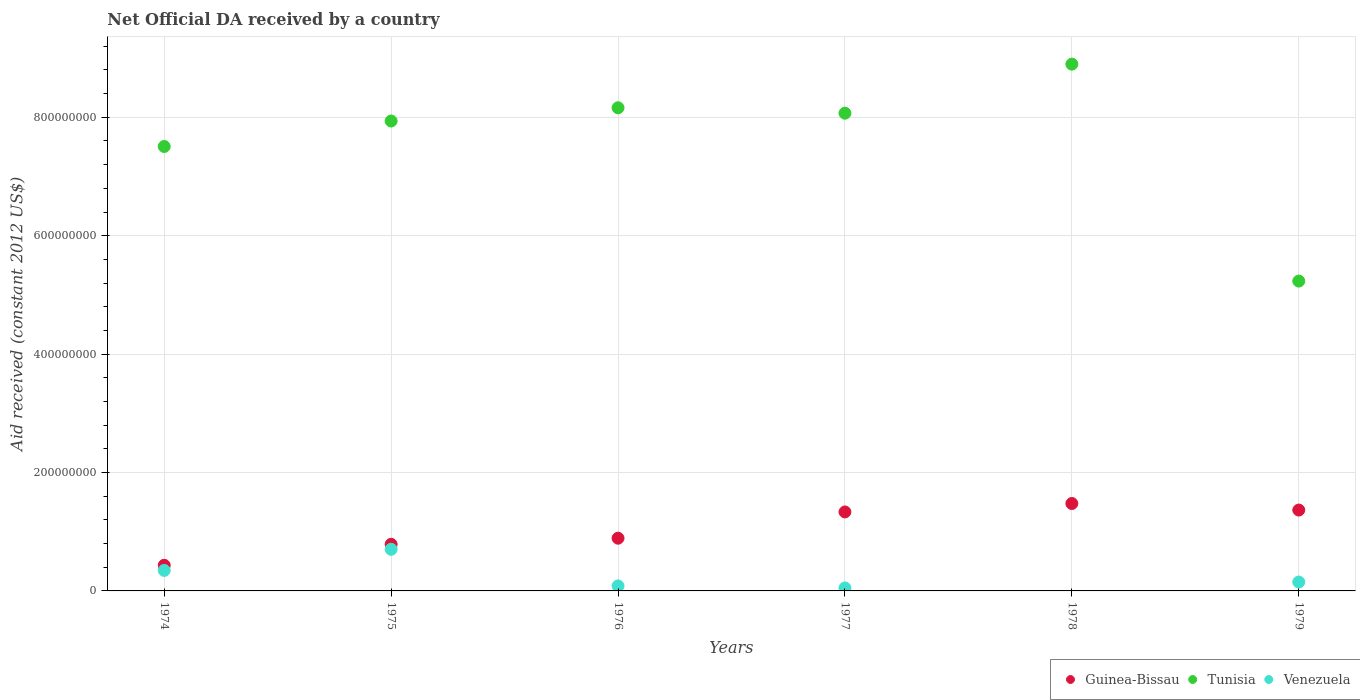How many different coloured dotlines are there?
Give a very brief answer. 3. Is the number of dotlines equal to the number of legend labels?
Provide a succinct answer. No. Across all years, what is the maximum net official development assistance aid received in Tunisia?
Your answer should be very brief. 8.90e+08. Across all years, what is the minimum net official development assistance aid received in Venezuela?
Ensure brevity in your answer.  0. In which year was the net official development assistance aid received in Guinea-Bissau maximum?
Ensure brevity in your answer.  1978. What is the total net official development assistance aid received in Venezuela in the graph?
Provide a short and direct response. 1.33e+08. What is the difference between the net official development assistance aid received in Guinea-Bissau in 1975 and that in 1976?
Offer a terse response. -1.03e+07. What is the difference between the net official development assistance aid received in Venezuela in 1979 and the net official development assistance aid received in Tunisia in 1978?
Keep it short and to the point. -8.75e+08. What is the average net official development assistance aid received in Guinea-Bissau per year?
Provide a succinct answer. 1.05e+08. In the year 1979, what is the difference between the net official development assistance aid received in Venezuela and net official development assistance aid received in Tunisia?
Provide a succinct answer. -5.08e+08. In how many years, is the net official development assistance aid received in Guinea-Bissau greater than 120000000 US$?
Give a very brief answer. 3. What is the ratio of the net official development assistance aid received in Guinea-Bissau in 1974 to that in 1976?
Ensure brevity in your answer.  0.49. Is the difference between the net official development assistance aid received in Venezuela in 1974 and 1979 greater than the difference between the net official development assistance aid received in Tunisia in 1974 and 1979?
Offer a very short reply. No. What is the difference between the highest and the second highest net official development assistance aid received in Guinea-Bissau?
Provide a short and direct response. 1.11e+07. What is the difference between the highest and the lowest net official development assistance aid received in Tunisia?
Provide a short and direct response. 3.66e+08. In how many years, is the net official development assistance aid received in Venezuela greater than the average net official development assistance aid received in Venezuela taken over all years?
Offer a very short reply. 2. Is it the case that in every year, the sum of the net official development assistance aid received in Tunisia and net official development assistance aid received in Venezuela  is greater than the net official development assistance aid received in Guinea-Bissau?
Ensure brevity in your answer.  Yes. Does the net official development assistance aid received in Venezuela monotonically increase over the years?
Your answer should be very brief. No. Is the net official development assistance aid received in Tunisia strictly greater than the net official development assistance aid received in Venezuela over the years?
Keep it short and to the point. Yes. Is the net official development assistance aid received in Tunisia strictly less than the net official development assistance aid received in Guinea-Bissau over the years?
Provide a short and direct response. No. How many years are there in the graph?
Provide a succinct answer. 6. What is the difference between two consecutive major ticks on the Y-axis?
Your answer should be very brief. 2.00e+08. Are the values on the major ticks of Y-axis written in scientific E-notation?
Your answer should be very brief. No. What is the title of the graph?
Make the answer very short. Net Official DA received by a country. Does "Central Europe" appear as one of the legend labels in the graph?
Provide a succinct answer. No. What is the label or title of the X-axis?
Keep it short and to the point. Years. What is the label or title of the Y-axis?
Keep it short and to the point. Aid received (constant 2012 US$). What is the Aid received (constant 2012 US$) in Guinea-Bissau in 1974?
Your answer should be compact. 4.33e+07. What is the Aid received (constant 2012 US$) in Tunisia in 1974?
Keep it short and to the point. 7.51e+08. What is the Aid received (constant 2012 US$) in Venezuela in 1974?
Your response must be concise. 3.46e+07. What is the Aid received (constant 2012 US$) of Guinea-Bissau in 1975?
Make the answer very short. 7.88e+07. What is the Aid received (constant 2012 US$) in Tunisia in 1975?
Your response must be concise. 7.94e+08. What is the Aid received (constant 2012 US$) in Venezuela in 1975?
Provide a short and direct response. 7.03e+07. What is the Aid received (constant 2012 US$) of Guinea-Bissau in 1976?
Your response must be concise. 8.91e+07. What is the Aid received (constant 2012 US$) in Tunisia in 1976?
Ensure brevity in your answer.  8.16e+08. What is the Aid received (constant 2012 US$) of Venezuela in 1976?
Make the answer very short. 8.46e+06. What is the Aid received (constant 2012 US$) of Guinea-Bissau in 1977?
Ensure brevity in your answer.  1.33e+08. What is the Aid received (constant 2012 US$) in Tunisia in 1977?
Offer a terse response. 8.07e+08. What is the Aid received (constant 2012 US$) of Guinea-Bissau in 1978?
Provide a succinct answer. 1.48e+08. What is the Aid received (constant 2012 US$) of Tunisia in 1978?
Your response must be concise. 8.90e+08. What is the Aid received (constant 2012 US$) of Guinea-Bissau in 1979?
Provide a succinct answer. 1.37e+08. What is the Aid received (constant 2012 US$) of Tunisia in 1979?
Offer a terse response. 5.23e+08. What is the Aid received (constant 2012 US$) in Venezuela in 1979?
Keep it short and to the point. 1.50e+07. Across all years, what is the maximum Aid received (constant 2012 US$) in Guinea-Bissau?
Your answer should be compact. 1.48e+08. Across all years, what is the maximum Aid received (constant 2012 US$) of Tunisia?
Your answer should be compact. 8.90e+08. Across all years, what is the maximum Aid received (constant 2012 US$) in Venezuela?
Your response must be concise. 7.03e+07. Across all years, what is the minimum Aid received (constant 2012 US$) of Guinea-Bissau?
Provide a short and direct response. 4.33e+07. Across all years, what is the minimum Aid received (constant 2012 US$) of Tunisia?
Ensure brevity in your answer.  5.23e+08. Across all years, what is the minimum Aid received (constant 2012 US$) in Venezuela?
Provide a short and direct response. 0. What is the total Aid received (constant 2012 US$) of Guinea-Bissau in the graph?
Your answer should be very brief. 6.29e+08. What is the total Aid received (constant 2012 US$) in Tunisia in the graph?
Provide a succinct answer. 4.58e+09. What is the total Aid received (constant 2012 US$) in Venezuela in the graph?
Ensure brevity in your answer.  1.33e+08. What is the difference between the Aid received (constant 2012 US$) in Guinea-Bissau in 1974 and that in 1975?
Keep it short and to the point. -3.55e+07. What is the difference between the Aid received (constant 2012 US$) of Tunisia in 1974 and that in 1975?
Your response must be concise. -4.30e+07. What is the difference between the Aid received (constant 2012 US$) of Venezuela in 1974 and that in 1975?
Offer a terse response. -3.57e+07. What is the difference between the Aid received (constant 2012 US$) in Guinea-Bissau in 1974 and that in 1976?
Your answer should be very brief. -4.57e+07. What is the difference between the Aid received (constant 2012 US$) in Tunisia in 1974 and that in 1976?
Your answer should be very brief. -6.54e+07. What is the difference between the Aid received (constant 2012 US$) of Venezuela in 1974 and that in 1976?
Offer a very short reply. 2.62e+07. What is the difference between the Aid received (constant 2012 US$) in Guinea-Bissau in 1974 and that in 1977?
Your answer should be very brief. -9.01e+07. What is the difference between the Aid received (constant 2012 US$) of Tunisia in 1974 and that in 1977?
Your answer should be very brief. -5.62e+07. What is the difference between the Aid received (constant 2012 US$) of Venezuela in 1974 and that in 1977?
Provide a short and direct response. 2.96e+07. What is the difference between the Aid received (constant 2012 US$) in Guinea-Bissau in 1974 and that in 1978?
Provide a short and direct response. -1.04e+08. What is the difference between the Aid received (constant 2012 US$) in Tunisia in 1974 and that in 1978?
Make the answer very short. -1.39e+08. What is the difference between the Aid received (constant 2012 US$) in Guinea-Bissau in 1974 and that in 1979?
Make the answer very short. -9.33e+07. What is the difference between the Aid received (constant 2012 US$) of Tunisia in 1974 and that in 1979?
Give a very brief answer. 2.27e+08. What is the difference between the Aid received (constant 2012 US$) in Venezuela in 1974 and that in 1979?
Provide a succinct answer. 1.96e+07. What is the difference between the Aid received (constant 2012 US$) of Guinea-Bissau in 1975 and that in 1976?
Offer a very short reply. -1.03e+07. What is the difference between the Aid received (constant 2012 US$) in Tunisia in 1975 and that in 1976?
Offer a very short reply. -2.24e+07. What is the difference between the Aid received (constant 2012 US$) in Venezuela in 1975 and that in 1976?
Provide a succinct answer. 6.18e+07. What is the difference between the Aid received (constant 2012 US$) of Guinea-Bissau in 1975 and that in 1977?
Keep it short and to the point. -5.46e+07. What is the difference between the Aid received (constant 2012 US$) of Tunisia in 1975 and that in 1977?
Ensure brevity in your answer.  -1.32e+07. What is the difference between the Aid received (constant 2012 US$) of Venezuela in 1975 and that in 1977?
Provide a succinct answer. 6.53e+07. What is the difference between the Aid received (constant 2012 US$) of Guinea-Bissau in 1975 and that in 1978?
Your answer should be compact. -6.89e+07. What is the difference between the Aid received (constant 2012 US$) in Tunisia in 1975 and that in 1978?
Your response must be concise. -9.61e+07. What is the difference between the Aid received (constant 2012 US$) of Guinea-Bissau in 1975 and that in 1979?
Provide a succinct answer. -5.78e+07. What is the difference between the Aid received (constant 2012 US$) of Tunisia in 1975 and that in 1979?
Keep it short and to the point. 2.70e+08. What is the difference between the Aid received (constant 2012 US$) in Venezuela in 1975 and that in 1979?
Your response must be concise. 5.53e+07. What is the difference between the Aid received (constant 2012 US$) of Guinea-Bissau in 1976 and that in 1977?
Your answer should be very brief. -4.44e+07. What is the difference between the Aid received (constant 2012 US$) of Tunisia in 1976 and that in 1977?
Ensure brevity in your answer.  9.16e+06. What is the difference between the Aid received (constant 2012 US$) of Venezuela in 1976 and that in 1977?
Your response must be concise. 3.46e+06. What is the difference between the Aid received (constant 2012 US$) of Guinea-Bissau in 1976 and that in 1978?
Your response must be concise. -5.86e+07. What is the difference between the Aid received (constant 2012 US$) in Tunisia in 1976 and that in 1978?
Keep it short and to the point. -7.37e+07. What is the difference between the Aid received (constant 2012 US$) in Guinea-Bissau in 1976 and that in 1979?
Your answer should be compact. -4.75e+07. What is the difference between the Aid received (constant 2012 US$) in Tunisia in 1976 and that in 1979?
Provide a short and direct response. 2.93e+08. What is the difference between the Aid received (constant 2012 US$) in Venezuela in 1976 and that in 1979?
Your answer should be very brief. -6.54e+06. What is the difference between the Aid received (constant 2012 US$) in Guinea-Bissau in 1977 and that in 1978?
Make the answer very short. -1.42e+07. What is the difference between the Aid received (constant 2012 US$) in Tunisia in 1977 and that in 1978?
Your response must be concise. -8.29e+07. What is the difference between the Aid received (constant 2012 US$) of Guinea-Bissau in 1977 and that in 1979?
Your answer should be very brief. -3.19e+06. What is the difference between the Aid received (constant 2012 US$) in Tunisia in 1977 and that in 1979?
Your answer should be compact. 2.84e+08. What is the difference between the Aid received (constant 2012 US$) in Venezuela in 1977 and that in 1979?
Give a very brief answer. -1.00e+07. What is the difference between the Aid received (constant 2012 US$) in Guinea-Bissau in 1978 and that in 1979?
Your answer should be very brief. 1.11e+07. What is the difference between the Aid received (constant 2012 US$) in Tunisia in 1978 and that in 1979?
Your answer should be compact. 3.66e+08. What is the difference between the Aid received (constant 2012 US$) of Guinea-Bissau in 1974 and the Aid received (constant 2012 US$) of Tunisia in 1975?
Offer a terse response. -7.50e+08. What is the difference between the Aid received (constant 2012 US$) in Guinea-Bissau in 1974 and the Aid received (constant 2012 US$) in Venezuela in 1975?
Your answer should be very brief. -2.70e+07. What is the difference between the Aid received (constant 2012 US$) of Tunisia in 1974 and the Aid received (constant 2012 US$) of Venezuela in 1975?
Your answer should be very brief. 6.80e+08. What is the difference between the Aid received (constant 2012 US$) of Guinea-Bissau in 1974 and the Aid received (constant 2012 US$) of Tunisia in 1976?
Offer a very short reply. -7.73e+08. What is the difference between the Aid received (constant 2012 US$) in Guinea-Bissau in 1974 and the Aid received (constant 2012 US$) in Venezuela in 1976?
Give a very brief answer. 3.49e+07. What is the difference between the Aid received (constant 2012 US$) in Tunisia in 1974 and the Aid received (constant 2012 US$) in Venezuela in 1976?
Provide a succinct answer. 7.42e+08. What is the difference between the Aid received (constant 2012 US$) of Guinea-Bissau in 1974 and the Aid received (constant 2012 US$) of Tunisia in 1977?
Make the answer very short. -7.64e+08. What is the difference between the Aid received (constant 2012 US$) of Guinea-Bissau in 1974 and the Aid received (constant 2012 US$) of Venezuela in 1977?
Your answer should be compact. 3.83e+07. What is the difference between the Aid received (constant 2012 US$) in Tunisia in 1974 and the Aid received (constant 2012 US$) in Venezuela in 1977?
Offer a very short reply. 7.46e+08. What is the difference between the Aid received (constant 2012 US$) in Guinea-Bissau in 1974 and the Aid received (constant 2012 US$) in Tunisia in 1978?
Your response must be concise. -8.46e+08. What is the difference between the Aid received (constant 2012 US$) in Guinea-Bissau in 1974 and the Aid received (constant 2012 US$) in Tunisia in 1979?
Provide a succinct answer. -4.80e+08. What is the difference between the Aid received (constant 2012 US$) of Guinea-Bissau in 1974 and the Aid received (constant 2012 US$) of Venezuela in 1979?
Keep it short and to the point. 2.83e+07. What is the difference between the Aid received (constant 2012 US$) in Tunisia in 1974 and the Aid received (constant 2012 US$) in Venezuela in 1979?
Provide a succinct answer. 7.36e+08. What is the difference between the Aid received (constant 2012 US$) of Guinea-Bissau in 1975 and the Aid received (constant 2012 US$) of Tunisia in 1976?
Your answer should be very brief. -7.37e+08. What is the difference between the Aid received (constant 2012 US$) of Guinea-Bissau in 1975 and the Aid received (constant 2012 US$) of Venezuela in 1976?
Ensure brevity in your answer.  7.03e+07. What is the difference between the Aid received (constant 2012 US$) in Tunisia in 1975 and the Aid received (constant 2012 US$) in Venezuela in 1976?
Ensure brevity in your answer.  7.85e+08. What is the difference between the Aid received (constant 2012 US$) of Guinea-Bissau in 1975 and the Aid received (constant 2012 US$) of Tunisia in 1977?
Provide a succinct answer. -7.28e+08. What is the difference between the Aid received (constant 2012 US$) in Guinea-Bissau in 1975 and the Aid received (constant 2012 US$) in Venezuela in 1977?
Your answer should be compact. 7.38e+07. What is the difference between the Aid received (constant 2012 US$) in Tunisia in 1975 and the Aid received (constant 2012 US$) in Venezuela in 1977?
Your answer should be compact. 7.89e+08. What is the difference between the Aid received (constant 2012 US$) of Guinea-Bissau in 1975 and the Aid received (constant 2012 US$) of Tunisia in 1978?
Your response must be concise. -8.11e+08. What is the difference between the Aid received (constant 2012 US$) of Guinea-Bissau in 1975 and the Aid received (constant 2012 US$) of Tunisia in 1979?
Make the answer very short. -4.45e+08. What is the difference between the Aid received (constant 2012 US$) in Guinea-Bissau in 1975 and the Aid received (constant 2012 US$) in Venezuela in 1979?
Offer a terse response. 6.38e+07. What is the difference between the Aid received (constant 2012 US$) of Tunisia in 1975 and the Aid received (constant 2012 US$) of Venezuela in 1979?
Your response must be concise. 7.79e+08. What is the difference between the Aid received (constant 2012 US$) in Guinea-Bissau in 1976 and the Aid received (constant 2012 US$) in Tunisia in 1977?
Provide a succinct answer. -7.18e+08. What is the difference between the Aid received (constant 2012 US$) in Guinea-Bissau in 1976 and the Aid received (constant 2012 US$) in Venezuela in 1977?
Make the answer very short. 8.41e+07. What is the difference between the Aid received (constant 2012 US$) of Tunisia in 1976 and the Aid received (constant 2012 US$) of Venezuela in 1977?
Your answer should be compact. 8.11e+08. What is the difference between the Aid received (constant 2012 US$) in Guinea-Bissau in 1976 and the Aid received (constant 2012 US$) in Tunisia in 1978?
Keep it short and to the point. -8.01e+08. What is the difference between the Aid received (constant 2012 US$) of Guinea-Bissau in 1976 and the Aid received (constant 2012 US$) of Tunisia in 1979?
Offer a terse response. -4.34e+08. What is the difference between the Aid received (constant 2012 US$) in Guinea-Bissau in 1976 and the Aid received (constant 2012 US$) in Venezuela in 1979?
Ensure brevity in your answer.  7.41e+07. What is the difference between the Aid received (constant 2012 US$) of Tunisia in 1976 and the Aid received (constant 2012 US$) of Venezuela in 1979?
Give a very brief answer. 8.01e+08. What is the difference between the Aid received (constant 2012 US$) of Guinea-Bissau in 1977 and the Aid received (constant 2012 US$) of Tunisia in 1978?
Give a very brief answer. -7.56e+08. What is the difference between the Aid received (constant 2012 US$) of Guinea-Bissau in 1977 and the Aid received (constant 2012 US$) of Tunisia in 1979?
Your response must be concise. -3.90e+08. What is the difference between the Aid received (constant 2012 US$) in Guinea-Bissau in 1977 and the Aid received (constant 2012 US$) in Venezuela in 1979?
Your response must be concise. 1.18e+08. What is the difference between the Aid received (constant 2012 US$) in Tunisia in 1977 and the Aid received (constant 2012 US$) in Venezuela in 1979?
Your answer should be very brief. 7.92e+08. What is the difference between the Aid received (constant 2012 US$) of Guinea-Bissau in 1978 and the Aid received (constant 2012 US$) of Tunisia in 1979?
Ensure brevity in your answer.  -3.76e+08. What is the difference between the Aid received (constant 2012 US$) in Guinea-Bissau in 1978 and the Aid received (constant 2012 US$) in Venezuela in 1979?
Your response must be concise. 1.33e+08. What is the difference between the Aid received (constant 2012 US$) of Tunisia in 1978 and the Aid received (constant 2012 US$) of Venezuela in 1979?
Keep it short and to the point. 8.75e+08. What is the average Aid received (constant 2012 US$) in Guinea-Bissau per year?
Your answer should be compact. 1.05e+08. What is the average Aid received (constant 2012 US$) in Tunisia per year?
Provide a short and direct response. 7.63e+08. What is the average Aid received (constant 2012 US$) of Venezuela per year?
Make the answer very short. 2.22e+07. In the year 1974, what is the difference between the Aid received (constant 2012 US$) in Guinea-Bissau and Aid received (constant 2012 US$) in Tunisia?
Provide a short and direct response. -7.07e+08. In the year 1974, what is the difference between the Aid received (constant 2012 US$) in Guinea-Bissau and Aid received (constant 2012 US$) in Venezuela?
Ensure brevity in your answer.  8.69e+06. In the year 1974, what is the difference between the Aid received (constant 2012 US$) of Tunisia and Aid received (constant 2012 US$) of Venezuela?
Provide a short and direct response. 7.16e+08. In the year 1975, what is the difference between the Aid received (constant 2012 US$) in Guinea-Bissau and Aid received (constant 2012 US$) in Tunisia?
Your answer should be compact. -7.15e+08. In the year 1975, what is the difference between the Aid received (constant 2012 US$) of Guinea-Bissau and Aid received (constant 2012 US$) of Venezuela?
Give a very brief answer. 8.49e+06. In the year 1975, what is the difference between the Aid received (constant 2012 US$) in Tunisia and Aid received (constant 2012 US$) in Venezuela?
Make the answer very short. 7.23e+08. In the year 1976, what is the difference between the Aid received (constant 2012 US$) in Guinea-Bissau and Aid received (constant 2012 US$) in Tunisia?
Ensure brevity in your answer.  -7.27e+08. In the year 1976, what is the difference between the Aid received (constant 2012 US$) of Guinea-Bissau and Aid received (constant 2012 US$) of Venezuela?
Offer a terse response. 8.06e+07. In the year 1976, what is the difference between the Aid received (constant 2012 US$) in Tunisia and Aid received (constant 2012 US$) in Venezuela?
Your answer should be compact. 8.08e+08. In the year 1977, what is the difference between the Aid received (constant 2012 US$) in Guinea-Bissau and Aid received (constant 2012 US$) in Tunisia?
Your response must be concise. -6.74e+08. In the year 1977, what is the difference between the Aid received (constant 2012 US$) in Guinea-Bissau and Aid received (constant 2012 US$) in Venezuela?
Your answer should be compact. 1.28e+08. In the year 1977, what is the difference between the Aid received (constant 2012 US$) of Tunisia and Aid received (constant 2012 US$) of Venezuela?
Keep it short and to the point. 8.02e+08. In the year 1978, what is the difference between the Aid received (constant 2012 US$) of Guinea-Bissau and Aid received (constant 2012 US$) of Tunisia?
Your response must be concise. -7.42e+08. In the year 1979, what is the difference between the Aid received (constant 2012 US$) in Guinea-Bissau and Aid received (constant 2012 US$) in Tunisia?
Your response must be concise. -3.87e+08. In the year 1979, what is the difference between the Aid received (constant 2012 US$) in Guinea-Bissau and Aid received (constant 2012 US$) in Venezuela?
Offer a very short reply. 1.22e+08. In the year 1979, what is the difference between the Aid received (constant 2012 US$) of Tunisia and Aid received (constant 2012 US$) of Venezuela?
Offer a very short reply. 5.08e+08. What is the ratio of the Aid received (constant 2012 US$) of Guinea-Bissau in 1974 to that in 1975?
Provide a short and direct response. 0.55. What is the ratio of the Aid received (constant 2012 US$) of Tunisia in 1974 to that in 1975?
Your answer should be very brief. 0.95. What is the ratio of the Aid received (constant 2012 US$) in Venezuela in 1974 to that in 1975?
Provide a short and direct response. 0.49. What is the ratio of the Aid received (constant 2012 US$) of Guinea-Bissau in 1974 to that in 1976?
Ensure brevity in your answer.  0.49. What is the ratio of the Aid received (constant 2012 US$) in Tunisia in 1974 to that in 1976?
Your answer should be very brief. 0.92. What is the ratio of the Aid received (constant 2012 US$) of Venezuela in 1974 to that in 1976?
Provide a succinct answer. 4.09. What is the ratio of the Aid received (constant 2012 US$) in Guinea-Bissau in 1974 to that in 1977?
Keep it short and to the point. 0.32. What is the ratio of the Aid received (constant 2012 US$) in Tunisia in 1974 to that in 1977?
Offer a terse response. 0.93. What is the ratio of the Aid received (constant 2012 US$) of Venezuela in 1974 to that in 1977?
Ensure brevity in your answer.  6.93. What is the ratio of the Aid received (constant 2012 US$) of Guinea-Bissau in 1974 to that in 1978?
Provide a succinct answer. 0.29. What is the ratio of the Aid received (constant 2012 US$) in Tunisia in 1974 to that in 1978?
Provide a short and direct response. 0.84. What is the ratio of the Aid received (constant 2012 US$) in Guinea-Bissau in 1974 to that in 1979?
Your answer should be very brief. 0.32. What is the ratio of the Aid received (constant 2012 US$) of Tunisia in 1974 to that in 1979?
Provide a succinct answer. 1.43. What is the ratio of the Aid received (constant 2012 US$) in Venezuela in 1974 to that in 1979?
Provide a short and direct response. 2.31. What is the ratio of the Aid received (constant 2012 US$) in Guinea-Bissau in 1975 to that in 1976?
Provide a short and direct response. 0.88. What is the ratio of the Aid received (constant 2012 US$) of Tunisia in 1975 to that in 1976?
Ensure brevity in your answer.  0.97. What is the ratio of the Aid received (constant 2012 US$) of Venezuela in 1975 to that in 1976?
Your answer should be compact. 8.31. What is the ratio of the Aid received (constant 2012 US$) in Guinea-Bissau in 1975 to that in 1977?
Your response must be concise. 0.59. What is the ratio of the Aid received (constant 2012 US$) in Tunisia in 1975 to that in 1977?
Offer a very short reply. 0.98. What is the ratio of the Aid received (constant 2012 US$) of Venezuela in 1975 to that in 1977?
Provide a short and direct response. 14.06. What is the ratio of the Aid received (constant 2012 US$) of Guinea-Bissau in 1975 to that in 1978?
Give a very brief answer. 0.53. What is the ratio of the Aid received (constant 2012 US$) in Tunisia in 1975 to that in 1978?
Keep it short and to the point. 0.89. What is the ratio of the Aid received (constant 2012 US$) of Guinea-Bissau in 1975 to that in 1979?
Make the answer very short. 0.58. What is the ratio of the Aid received (constant 2012 US$) of Tunisia in 1975 to that in 1979?
Keep it short and to the point. 1.52. What is the ratio of the Aid received (constant 2012 US$) of Venezuela in 1975 to that in 1979?
Provide a succinct answer. 4.69. What is the ratio of the Aid received (constant 2012 US$) of Guinea-Bissau in 1976 to that in 1977?
Provide a short and direct response. 0.67. What is the ratio of the Aid received (constant 2012 US$) in Tunisia in 1976 to that in 1977?
Ensure brevity in your answer.  1.01. What is the ratio of the Aid received (constant 2012 US$) in Venezuela in 1976 to that in 1977?
Your response must be concise. 1.69. What is the ratio of the Aid received (constant 2012 US$) in Guinea-Bissau in 1976 to that in 1978?
Provide a succinct answer. 0.6. What is the ratio of the Aid received (constant 2012 US$) in Tunisia in 1976 to that in 1978?
Keep it short and to the point. 0.92. What is the ratio of the Aid received (constant 2012 US$) in Guinea-Bissau in 1976 to that in 1979?
Ensure brevity in your answer.  0.65. What is the ratio of the Aid received (constant 2012 US$) in Tunisia in 1976 to that in 1979?
Your answer should be compact. 1.56. What is the ratio of the Aid received (constant 2012 US$) of Venezuela in 1976 to that in 1979?
Your response must be concise. 0.56. What is the ratio of the Aid received (constant 2012 US$) in Guinea-Bissau in 1977 to that in 1978?
Give a very brief answer. 0.9. What is the ratio of the Aid received (constant 2012 US$) in Tunisia in 1977 to that in 1978?
Keep it short and to the point. 0.91. What is the ratio of the Aid received (constant 2012 US$) of Guinea-Bissau in 1977 to that in 1979?
Make the answer very short. 0.98. What is the ratio of the Aid received (constant 2012 US$) in Tunisia in 1977 to that in 1979?
Give a very brief answer. 1.54. What is the ratio of the Aid received (constant 2012 US$) in Venezuela in 1977 to that in 1979?
Keep it short and to the point. 0.33. What is the ratio of the Aid received (constant 2012 US$) in Guinea-Bissau in 1978 to that in 1979?
Your answer should be compact. 1.08. What is the ratio of the Aid received (constant 2012 US$) in Tunisia in 1978 to that in 1979?
Ensure brevity in your answer.  1.7. What is the difference between the highest and the second highest Aid received (constant 2012 US$) in Guinea-Bissau?
Your response must be concise. 1.11e+07. What is the difference between the highest and the second highest Aid received (constant 2012 US$) in Tunisia?
Your answer should be very brief. 7.37e+07. What is the difference between the highest and the second highest Aid received (constant 2012 US$) in Venezuela?
Your answer should be compact. 3.57e+07. What is the difference between the highest and the lowest Aid received (constant 2012 US$) of Guinea-Bissau?
Give a very brief answer. 1.04e+08. What is the difference between the highest and the lowest Aid received (constant 2012 US$) in Tunisia?
Your answer should be very brief. 3.66e+08. What is the difference between the highest and the lowest Aid received (constant 2012 US$) of Venezuela?
Make the answer very short. 7.03e+07. 